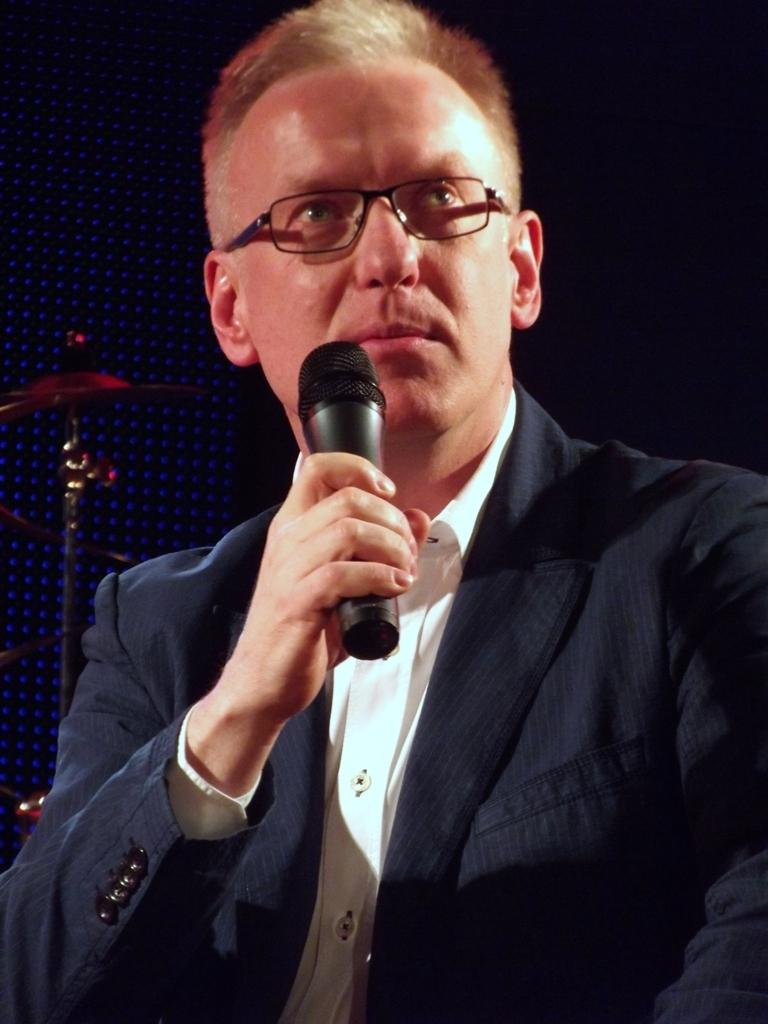Who is the main subject in the image? There is a man in the image. Where is the man located in the image? The man is sitting at the center of the image. What is the man holding in his hand? The man is holding a mic in his hand. In which direction is the man facing? The man is facing the front side direction. Can you see the man taking a bite of something in the image? There is no indication in the image that the man is taking a bite of anything; he is holding a mic in his hand. 